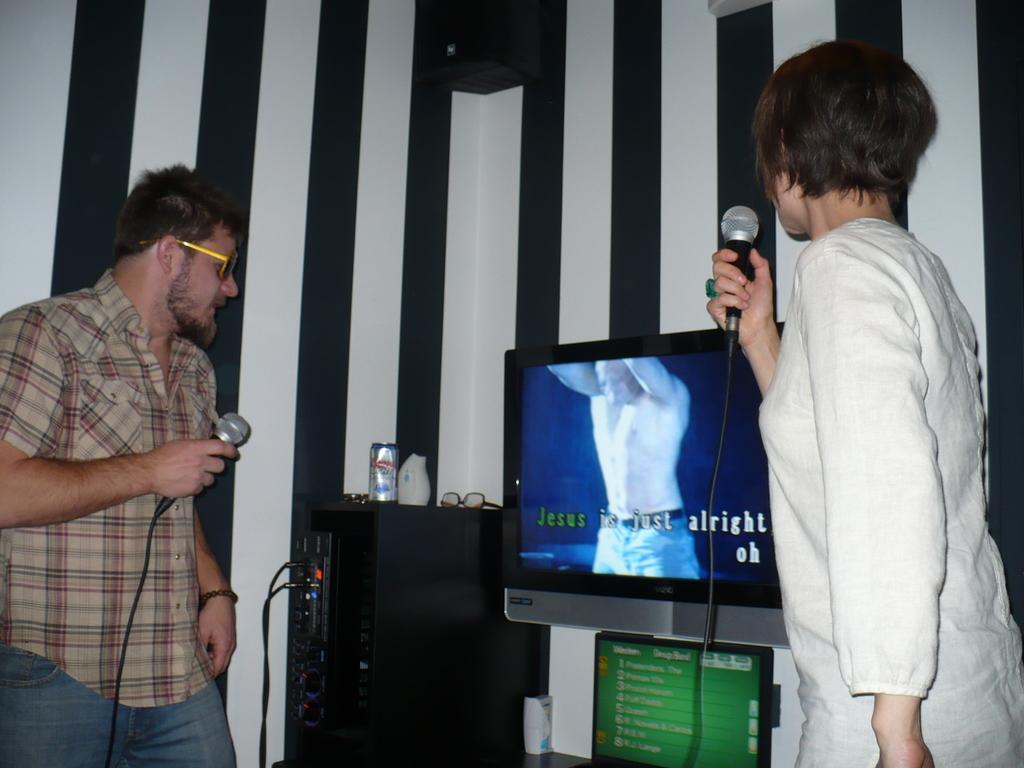How would you summarize this image in a sentence or two? In this image, there are a few people holding microphones. We can see the screen and a board with some text. We can see a black colored object with some wires. We can also see spectacles, a coke tin. We can see the wall and an object at the top. 